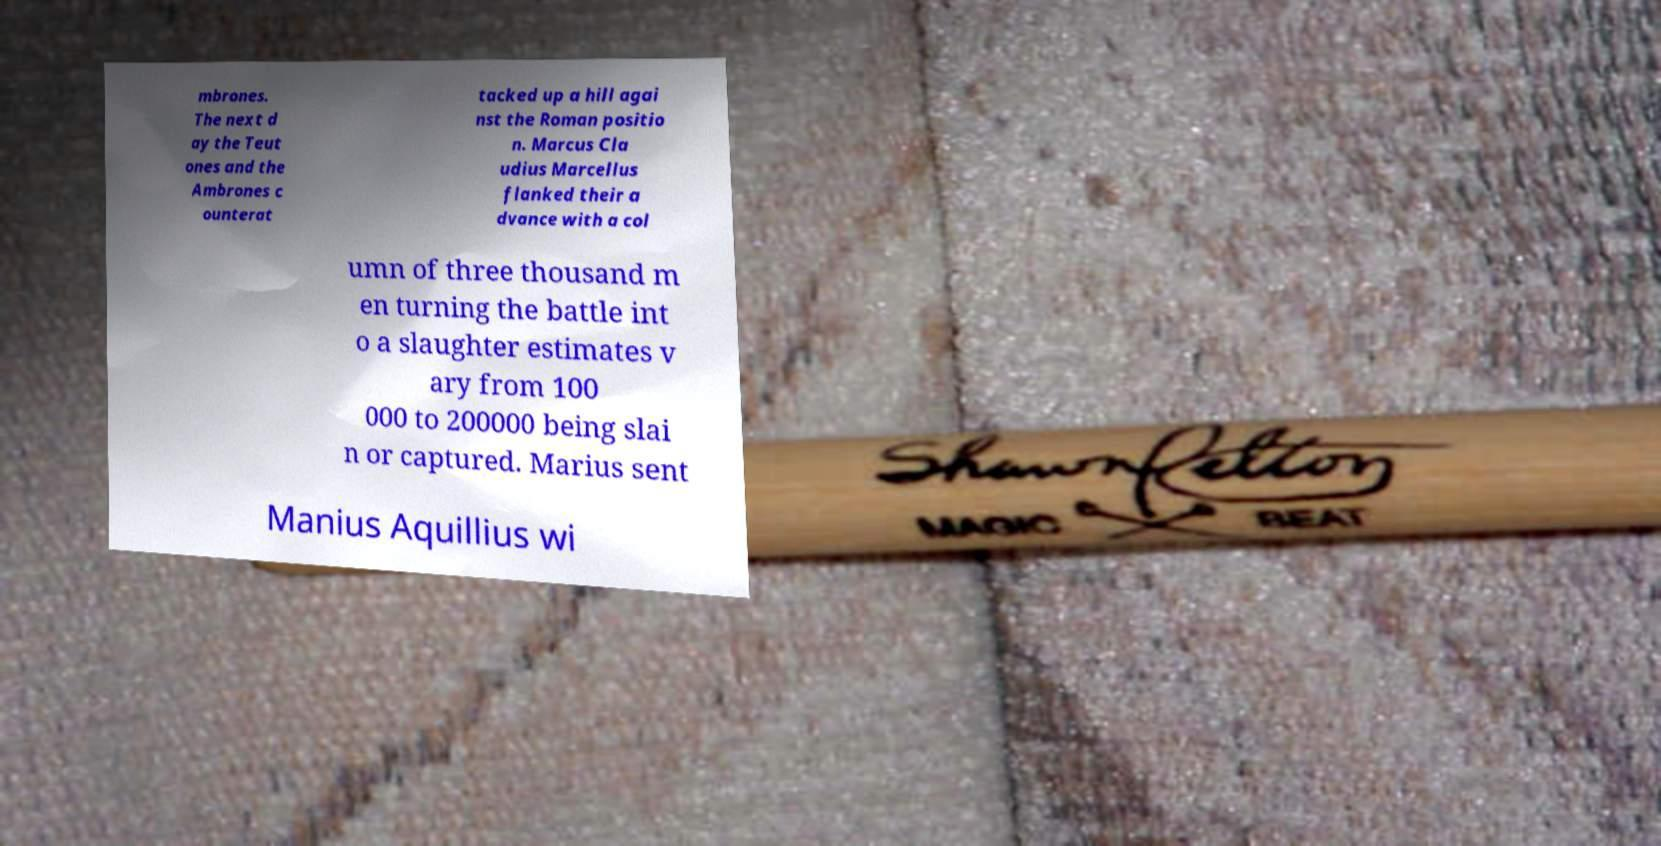Please read and relay the text visible in this image. What does it say? mbrones. The next d ay the Teut ones and the Ambrones c ounterat tacked up a hill agai nst the Roman positio n. Marcus Cla udius Marcellus flanked their a dvance with a col umn of three thousand m en turning the battle int o a slaughter estimates v ary from 100 000 to 200000 being slai n or captured. Marius sent Manius Aquillius wi 